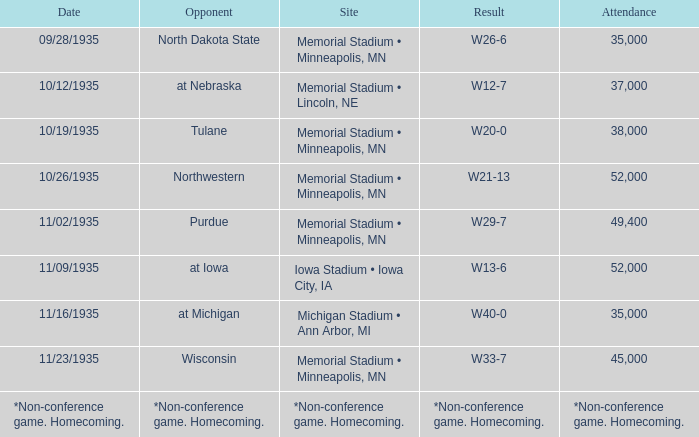How many spectators attended the game on 11/09/1935? 52000.0. 